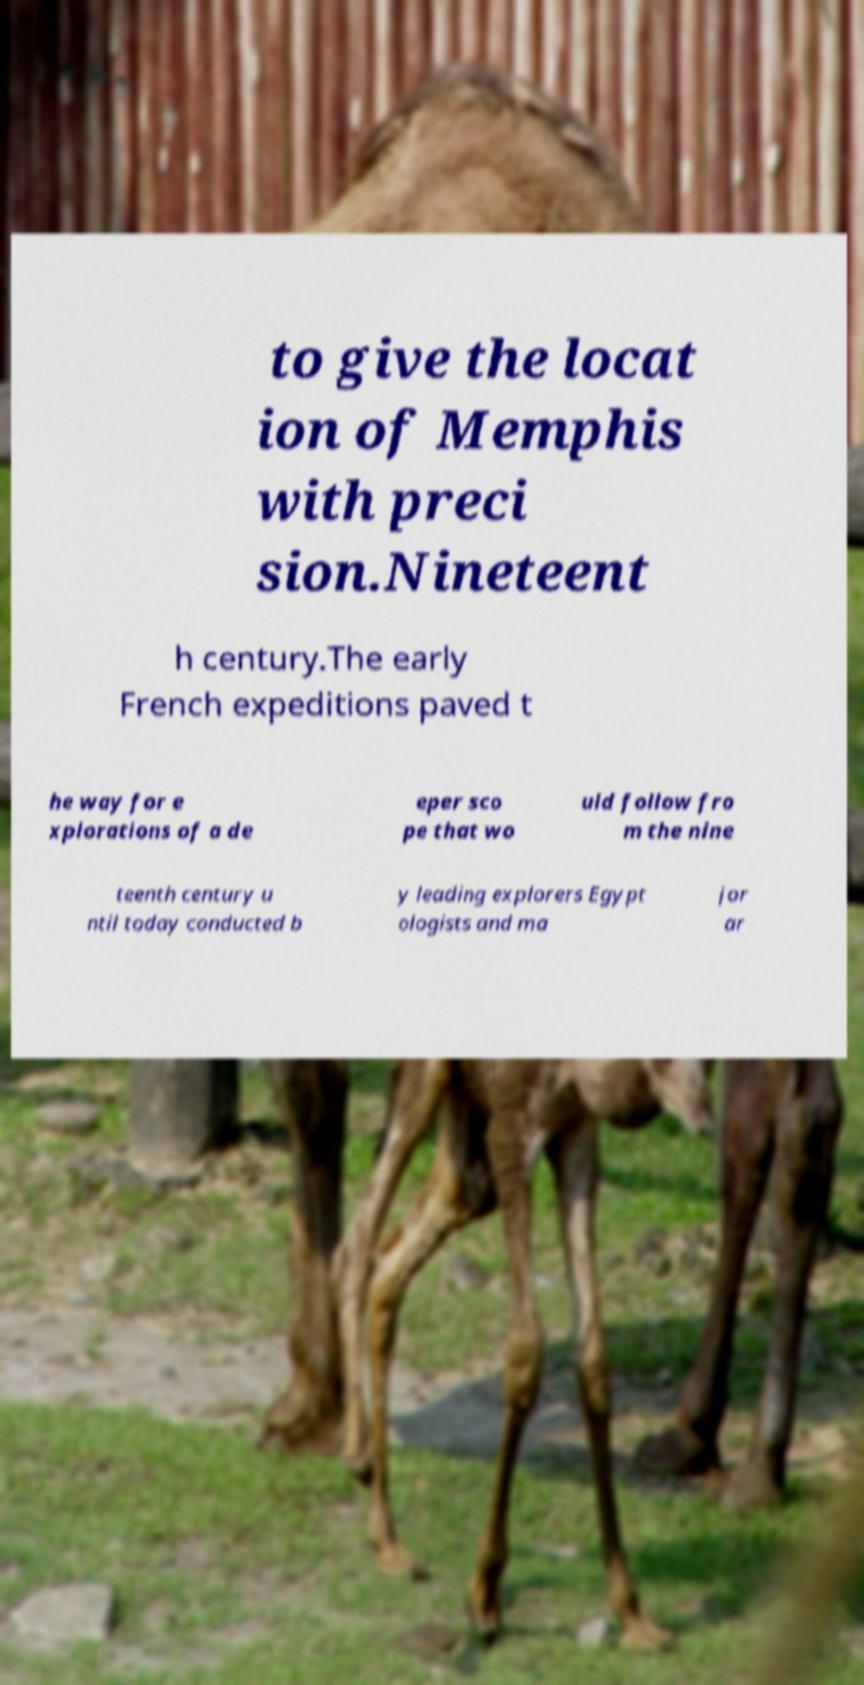I need the written content from this picture converted into text. Can you do that? to give the locat ion of Memphis with preci sion.Nineteent h century.The early French expeditions paved t he way for e xplorations of a de eper sco pe that wo uld follow fro m the nine teenth century u ntil today conducted b y leading explorers Egypt ologists and ma jor ar 